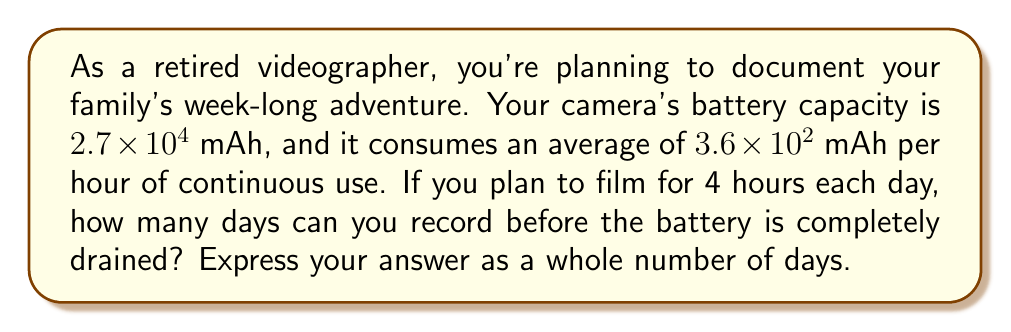Provide a solution to this math problem. To solve this problem, we'll follow these steps:

1) First, let's calculate the daily battery consumption:
   Daily consumption = Hours of use per day × Consumption per hour
   $$ 4 \text{ hours} \times 3.6 \times 10^2 \text{ mAh/hour} = 1.44 \times 10^3 \text{ mAh/day} $$

2) Now, we need to find out how many days the battery will last:
   Number of days = Total battery capacity ÷ Daily consumption
   $$ \frac{2.7 \times 10^4 \text{ mAh}}{1.44 \times 10^3 \text{ mAh/day}} $$

3) To divide these numbers in exponential notation, we can subtract the exponents:
   $$ 2.7 \times 10^4 \div (1.44 \times 10^3) = \frac{2.7}{1.44} \times 10^{4-3} = 1.875 \times 10^1 \text{ days} $$

4) $1.875 \times 10^1$ is equal to 18.75 days.

5) Since we're asked for a whole number of days, we round down to 18 days.
Answer: 18 days 